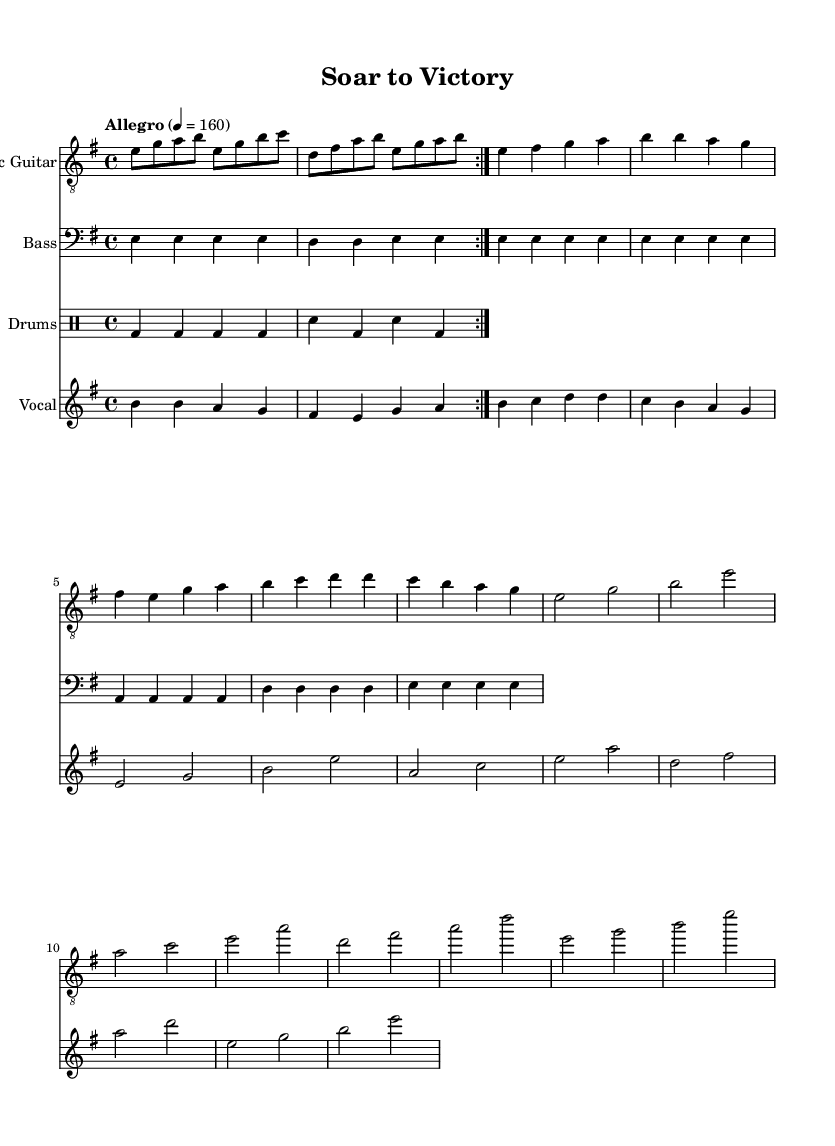What is the key signature of this music? The key signature is indicated at the beginning of the sheet music, showing one sharp in the key signature box, which corresponds to E minor.
Answer: E minor What is the time signature of this piece? The time signature is given in the upper part of the sheet music, which indicates four beats per measure, represented as 4/4.
Answer: 4/4 What is the tempo marking for this song? The tempo marking appears in the score, indicating a fast pace of 160 beats per minute, denoted by "Allegro" followed by the metronome marking.
Answer: 160 How many measures are repeated in the guitar part? The guitar part includes a repeat section indicated by the "volta" markings, specifically it repeats two times mentioned throughout the score.
Answer: 2 What is the overall theme of the lyrics? The lyrics emphasize themes of resilience and determination, particularly about overcoming adversity and striving to achieve goals, as indicated by the phrases in the lyrics.
Answer: Overcoming adversity What kind of phrases are predominantly used in the vocal part? The vocal part utilizes a mix of repeated notes and ascending phrases with a combination of longer and shorter note values to convey a powerful emotional message.
Answer: Ascending phrases What instrumental roles accompany the vocals in this song? The instrumental roles consist of an electric guitar for melody, bass guitar for harmonic support, and drums to provide rhythm, all complementing the vocal line in a typical metal arrangement.
Answer: Electric guitar, bass, drums 